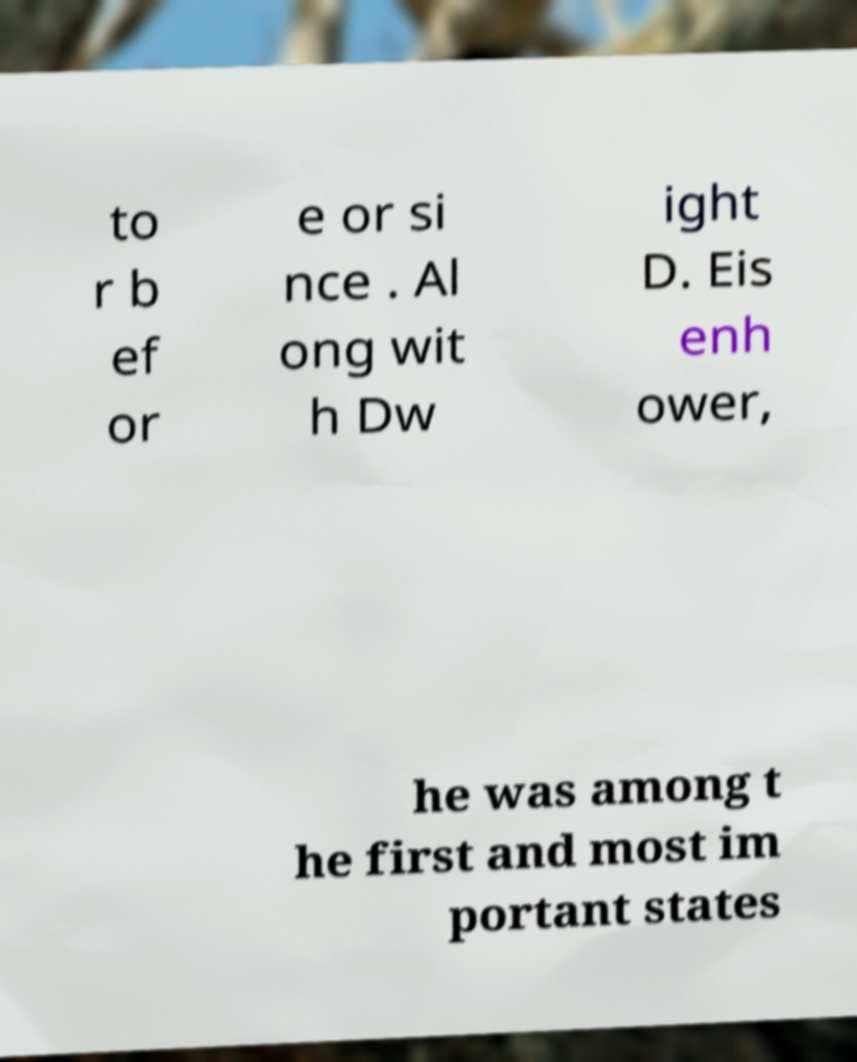Can you accurately transcribe the text from the provided image for me? to r b ef or e or si nce . Al ong wit h Dw ight D. Eis enh ower, he was among t he first and most im portant states 